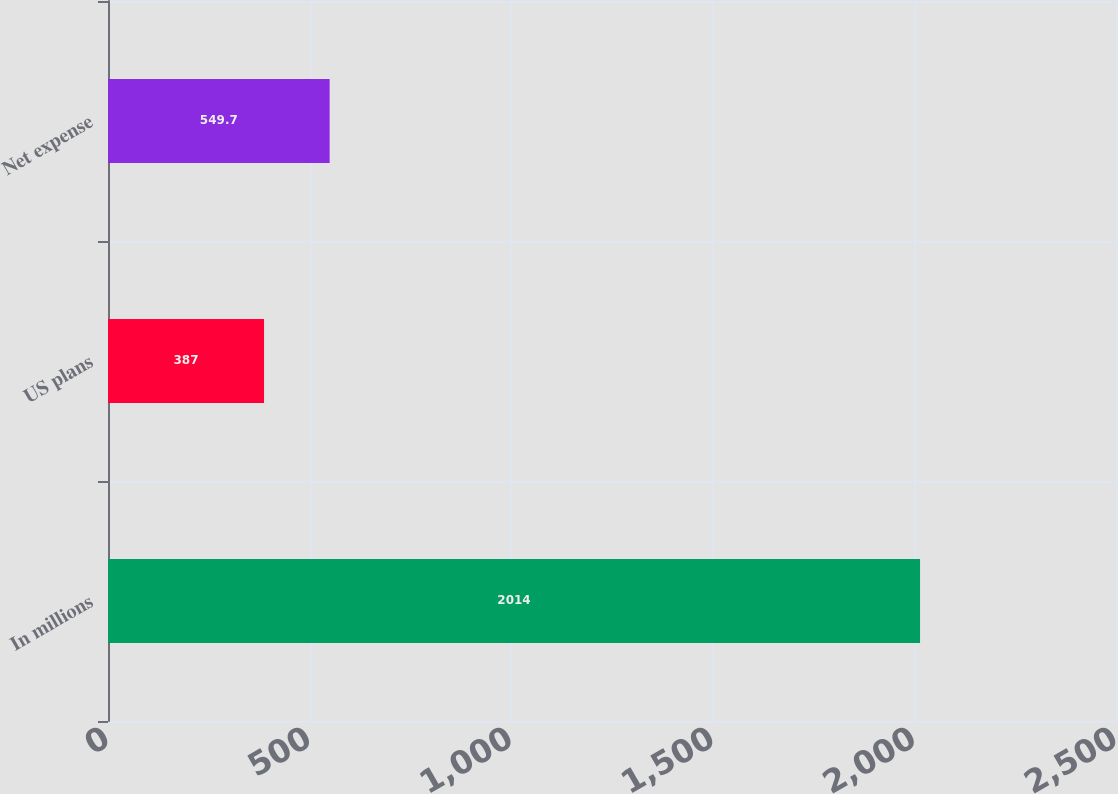Convert chart to OTSL. <chart><loc_0><loc_0><loc_500><loc_500><bar_chart><fcel>In millions<fcel>US plans<fcel>Net expense<nl><fcel>2014<fcel>387<fcel>549.7<nl></chart> 